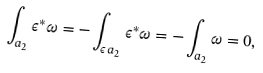<formula> <loc_0><loc_0><loc_500><loc_500>\int _ { a _ { 2 } } \epsilon ^ { * } \omega = - \int _ { \epsilon \, a _ { 2 } } \epsilon ^ { * } \omega = - \int _ { a _ { 2 } } \omega = 0 ,</formula> 